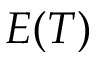<formula> <loc_0><loc_0><loc_500><loc_500>E ( T )</formula> 